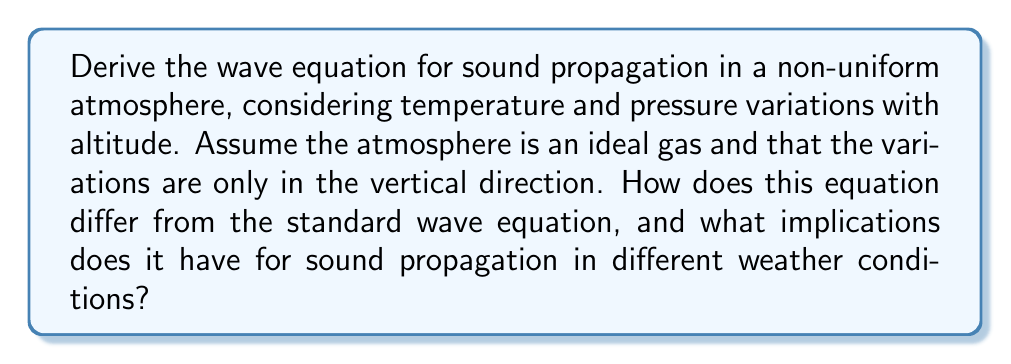What is the answer to this math problem? To derive the wave equation for sound propagation in a non-uniform atmosphere, we need to consider the following steps:

1) Start with the basic equations of fluid dynamics:

   a) Continuity equation:
      $$\frac{\partial \rho}{\partial t} + \nabla \cdot (\rho \mathbf{v}) = 0$$

   b) Momentum equation (Euler's equation):
      $$\rho \frac{\partial \mathbf{v}}{\partial t} + \rho (\mathbf{v} \cdot \nabla)\mathbf{v} = -\nabla p$$

   c) Equation of state for an ideal gas:
      $$p = \rho R T$$

   Where $\rho$ is density, $\mathbf{v}$ is velocity, $p$ is pressure, $R$ is the gas constant, and $T$ is temperature.

2) Assume small perturbations around equilibrium values:
   $$\rho = \rho_0(z) + \rho'$$
   $$p = p_0(z) + p'$$
   $$\mathbf{v} = \mathbf{v}'$$
   $$T = T_0(z) + T'$$

   Where subscript 0 denotes equilibrium values that vary with altitude $z$, and primes denote small perturbations.

3) Linearize the equations by neglecting products of small quantities:

   a) Continuity equation:
      $$\frac{\partial \rho'}{\partial t} + \nabla \cdot (\rho_0 \mathbf{v}') = 0$$

   b) Momentum equation:
      $$\rho_0 \frac{\partial \mathbf{v}'}{\partial t} = -\nabla p'$$

   c) Linearized equation of state:
      $$p' = c_0^2 \rho'$$
      Where $c_0^2 = \gamma R T_0(z)$ is the square of the speed of sound, and $\gamma$ is the ratio of specific heats.

4) Combine these equations:

   a) Take the time derivative of the continuity equation:
      $$\frac{\partial^2 \rho'}{\partial t^2} + \nabla \cdot (\rho_0 \frac{\partial \mathbf{v}'}{\partial t}) = 0$$

   b) Substitute the momentum equation:
      $$\frac{\partial^2 \rho'}{\partial t^2} - \nabla \cdot (\nabla p') = 0$$

   c) Use the linearized equation of state:
      $$\frac{\partial^2 p'}{\partial t^2} - \nabla \cdot (c_0^2 \nabla p') = 0$$

5) Expand the divergence term:
   $$\frac{\partial^2 p'}{\partial t^2} - c_0^2 \nabla^2 p' - \nabla c_0^2 \cdot \nabla p' = 0$$

This is the wave equation for sound propagation in a non-uniform atmosphere. The main difference from the standard wave equation is the additional term $\nabla c_0^2 \cdot \nabla p'$, which arises due to the variation of sound speed with altitude.

Implications for sound propagation in different weather conditions:

1) Sound speed variations: The speed of sound changes with altitude due to temperature variations, affecting wave propagation.

2) Refraction: Sound waves can be bent due to gradients in the sound speed, leading to phenomena like sound channels or shadow zones.

3) Reflection: Sharp changes in temperature or wind can cause partial reflection of sound waves.

4) Atmospheric ducting: Under certain temperature inversion conditions, sound can be trapped in atmospheric layers, propagating over long distances.

5) Weather-dependent propagation: Different weather conditions (temperature gradients, wind shear) can significantly affect how sound travels through the atmosphere.
Answer: The wave equation for sound propagation in a non-uniform atmosphere is:

$$\frac{\partial^2 p'}{\partial t^2} - c_0^2 \nabla^2 p' - \nabla c_0^2 \cdot \nabla p' = 0$$

Where $p'$ is the pressure perturbation, $t$ is time, and $c_0^2 = \gamma R T_0(z)$ is the square of the speed of sound that varies with altitude $z$. This equation differs from the standard wave equation by the additional term $\nabla c_0^2 \cdot \nabla p'$, which accounts for the non-uniform nature of the atmosphere and leads to various weather-dependent propagation effects. 